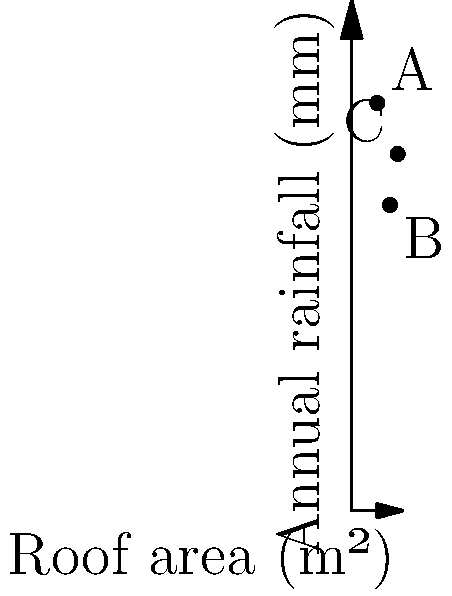As sustainable homeowners, you're designing a rainwater harvesting system for three different house designs. Given the graph showing roof area and annual rainfall for locations A, B, and C, which location would yield the highest annual rainwater collection volume? Assume a collection efficiency of 80%. To determine which location would yield the highest annual rainwater collection volume, we need to calculate the potential rainwater collection for each location using the formula:

$$V = A \times R \times E$$

Where:
$V$ = Annual rainwater collection volume (m³)
$A$ = Roof area (m²)
$R$ = Annual rainfall (m)
$E$ = Collection efficiency (0.80)

Let's calculate for each location:

1. Location A:
   $A = 50$ m², $R = 800$ mm = $0.8$ m
   $$V_A = 50 \times 0.8 \times 0.80 = 32$ m³$$

2. Location B:
   $A = 75$ m², $R = 600$ mm = $0.6$ m
   $$V_B = 75 \times 0.6 \times 0.80 = 36$ m³$$

3. Location C:
   $A = 90$ m², $R = 700$ mm = $0.7$ m
   $$V_C = 90 \times 0.7 \times 0.80 = 50.4$ m³$$

Comparing the results, we can see that Location C would yield the highest annual rainwater collection volume.
Answer: Location C (50.4 m³) 